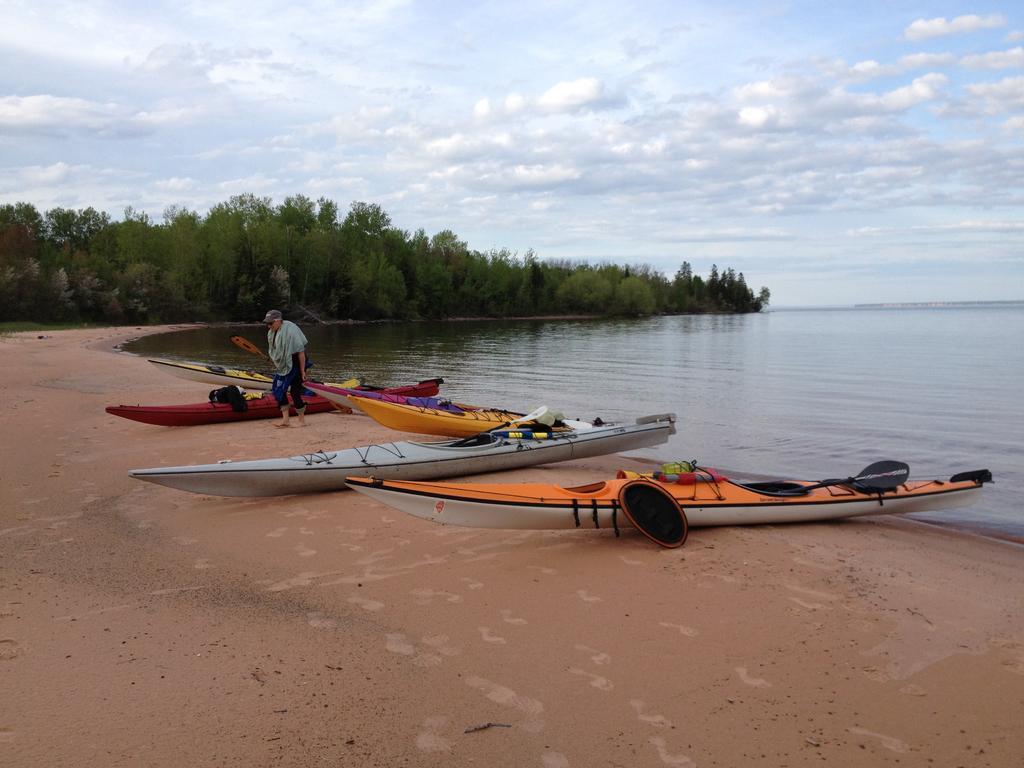Can you describe this image briefly? In this image we can see a few boats, trees, water and a person, in the background, we can see the sky with clouds. 